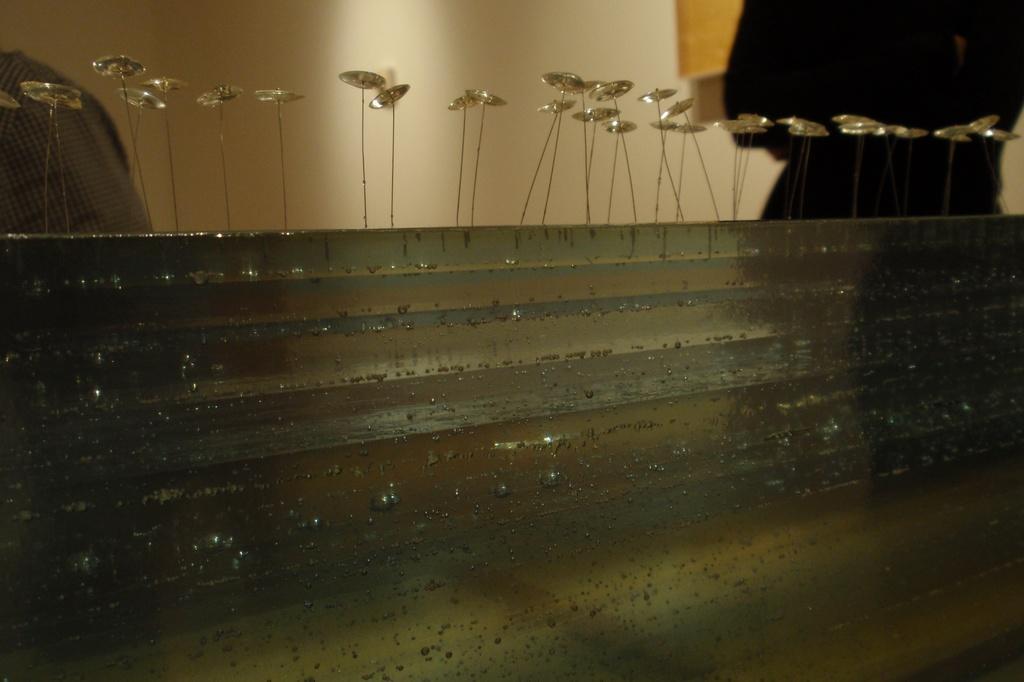In one or two sentences, can you explain what this image depicts? There is a wall with some decorative items. In the back there are people and wall. 